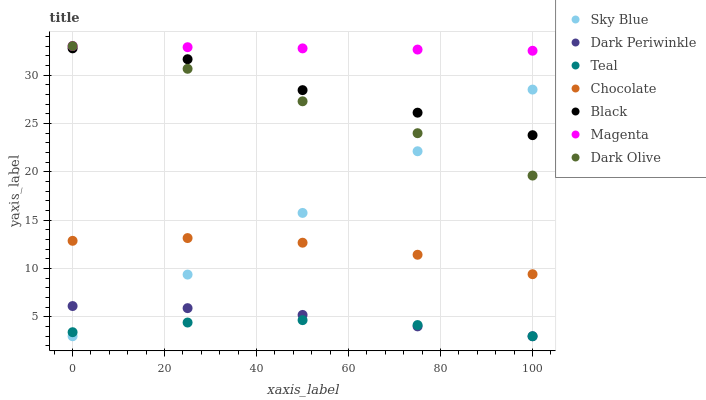Does Teal have the minimum area under the curve?
Answer yes or no. Yes. Does Magenta have the maximum area under the curve?
Answer yes or no. Yes. Does Chocolate have the minimum area under the curve?
Answer yes or no. No. Does Chocolate have the maximum area under the curve?
Answer yes or no. No. Is Sky Blue the smoothest?
Answer yes or no. Yes. Is Black the roughest?
Answer yes or no. Yes. Is Chocolate the smoothest?
Answer yes or no. No. Is Chocolate the roughest?
Answer yes or no. No. Does Teal have the lowest value?
Answer yes or no. Yes. Does Chocolate have the lowest value?
Answer yes or no. No. Does Magenta have the highest value?
Answer yes or no. Yes. Does Chocolate have the highest value?
Answer yes or no. No. Is Sky Blue less than Magenta?
Answer yes or no. Yes. Is Chocolate greater than Teal?
Answer yes or no. Yes. Does Magenta intersect Dark Olive?
Answer yes or no. Yes. Is Magenta less than Dark Olive?
Answer yes or no. No. Is Magenta greater than Dark Olive?
Answer yes or no. No. Does Sky Blue intersect Magenta?
Answer yes or no. No. 